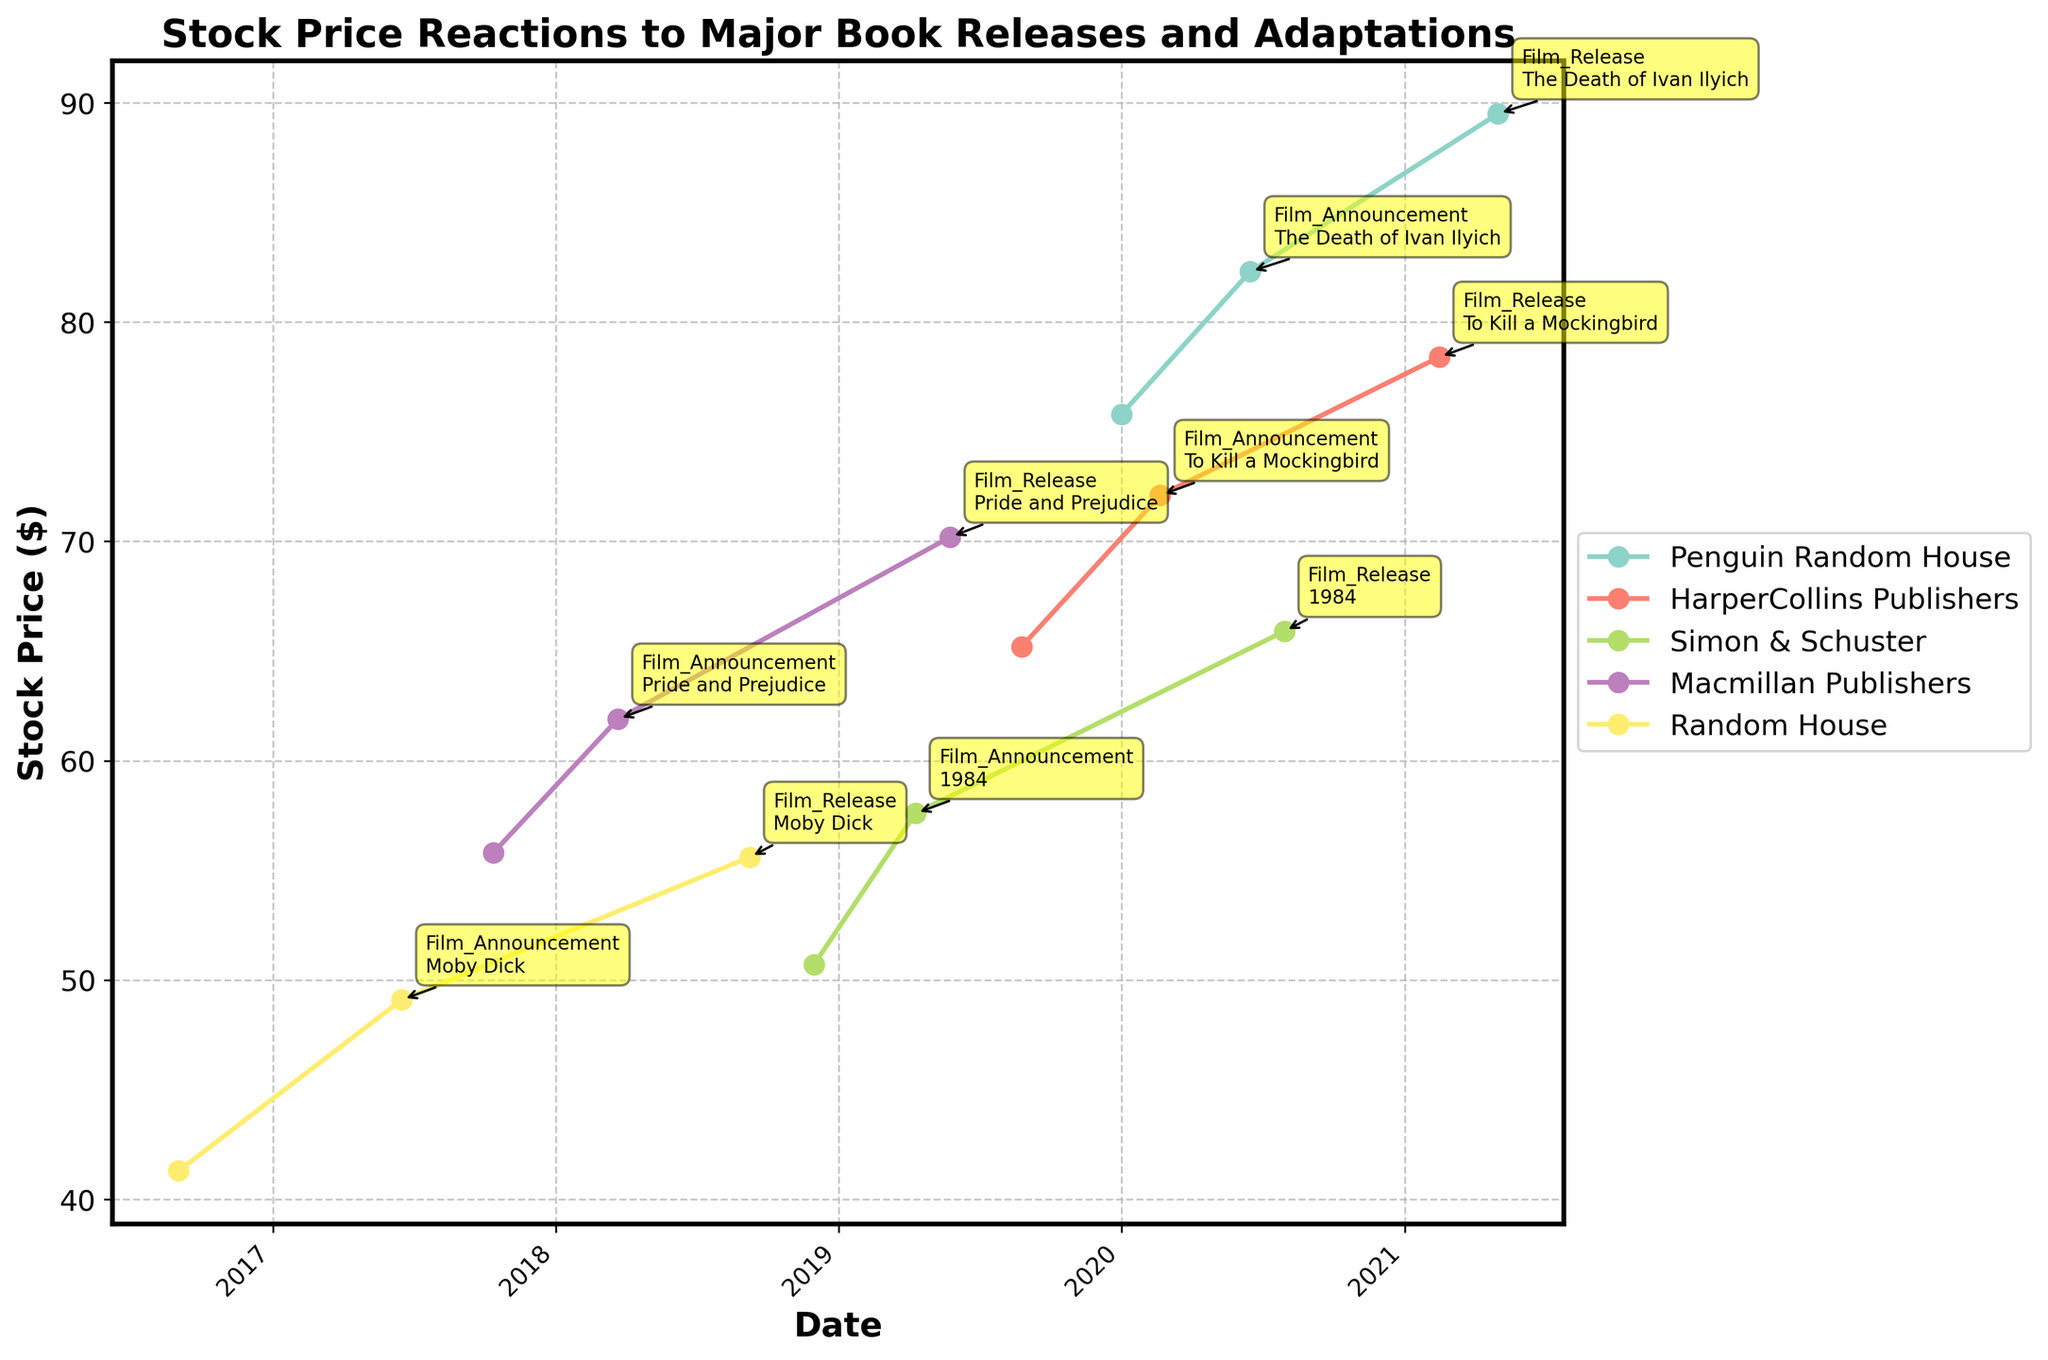what is the title of the figure? The title is located at the top center of the figure and provides an overview of what the figure depicts.
Answer: Stock Price Reactions to Major Book Releases and Adaptations Which company's stock price increased the most on the day of a film release? Look at the stock price before and after each film release event for each company, then find the largest increase.
Answer: Penguin Random House How many companies are depicted in the figure? Count the number of unique companies from the legend on the right side of the figure.
Answer: 5 What is the overall trend in stock prices after the film announcement for all companies? Look at the stock prices before and after the film announcement points for all companies. Determine if they generally increase, decrease, or stay the same.
Answer: Increase Which company had the highest stock price on the latest date in the figure? Identify the latest date in the x-axis, then find the corresponding stock price and company.
Answer: HarperCollins Publishers What was the stock price of Simon & Schuster two months after the book release of "1984"? Find the book release date for "1984" under Simon & Schuster, then identify the stock price two months later (around January 30, 2019).
Answer: 57.60 Compare the stock price of "Pride and Prejudice" book release and film announcement for Macmillan Publishers. Find the dates and corresponding stock prices for the book release and film announcement of "Pride and Prejudice" under Macmillan Publishers.
Answer: Book Release: $55.80, Film Announcement: $61.90 Which event type appears most frequently in the figure? Count the number of times each event type appears next to the data points annotated in the figure.
Answer: Film Release What is the difference between the highest and lowest stock prices for Random House? Identify the highest and lowest stock prices for Random House by examining the y-axis values corresponding to Random House data points, then calculate the difference.
Answer: $14.30 On average, how much does the stock price of HarperCollins Publishers increase from book release to film release? Subtract stock prices at book release from the stock prices at film release for HarperCollins Publishers. Divide the difference by the number of events.
Answer: $13.20 